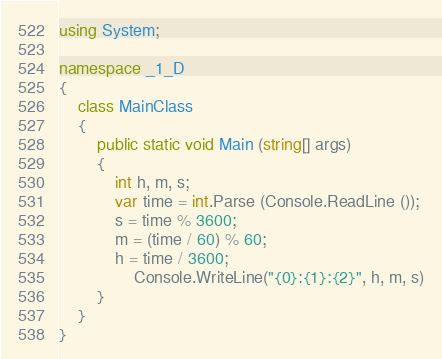<code> <loc_0><loc_0><loc_500><loc_500><_C#_>using System;

namespace _1_D
{
	class MainClass
	{
		public static void Main (string[] args)
		{
			int h, m, s;
			var time = int.Parse (Console.ReadLine ());
			s = time % 3600;
			m = (time / 60) % 60;
			h = time / 3600;
				Console.WriteLine("{0}:{1}:{2}", h, m, s)
		}
	}
}</code> 